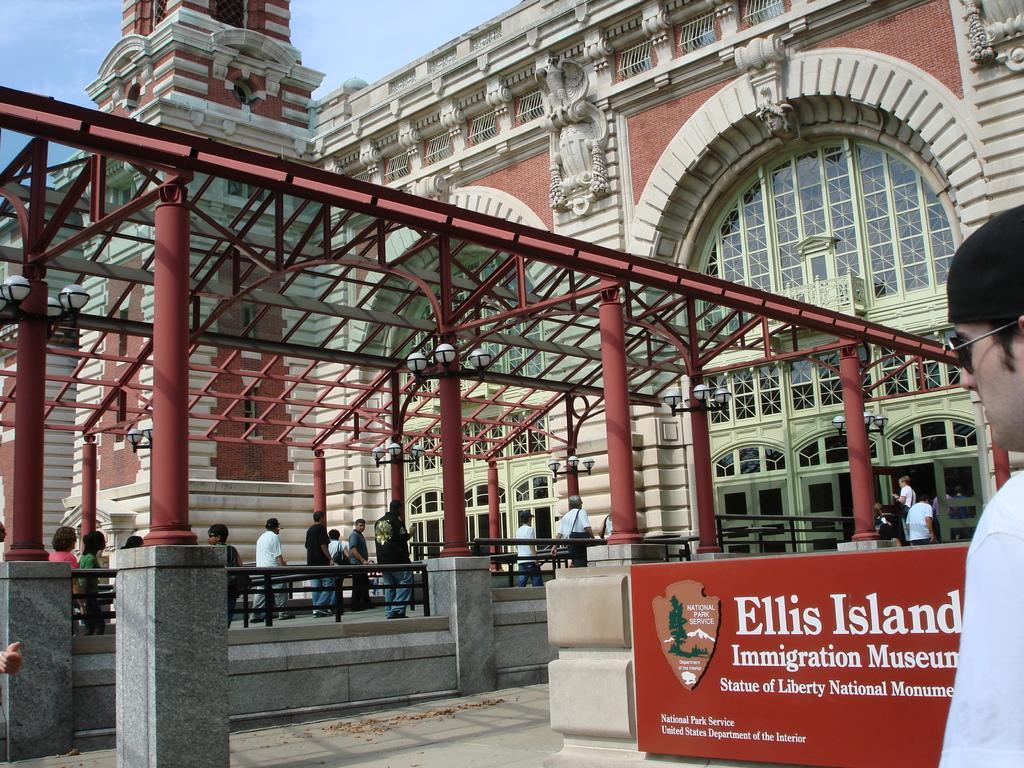Could you give a brief overview of what you see in this image? This picture shows a building and we see few people walking and we see a man wore sunglasses and cap on his head and we see a name board on the wall and we see a blue cloudy sky. 